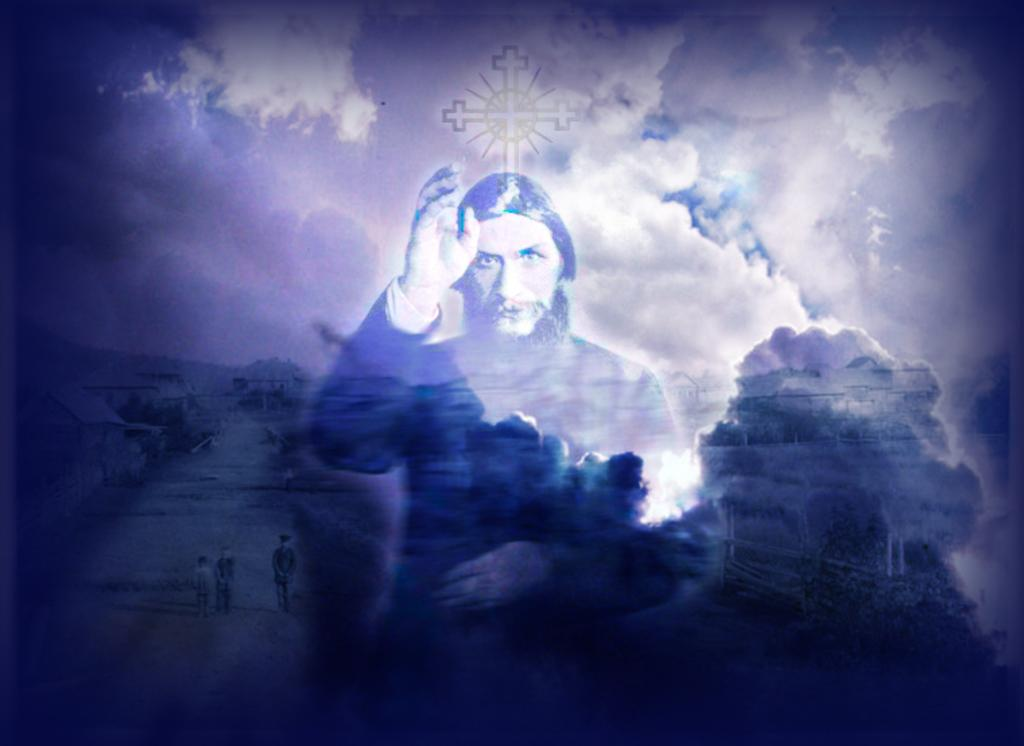What type of image is present in the picture? There is a graphical image in the picture. What are the people in the picture doing? There are people walking in the picture. How many humans are visible in the picture? There is another human in the picture, making a total of three people. What symbol can be seen in the picture? There is a cross symbol in the picture. What is visible in the sky in the picture? Clouds are visible in the sky. What type of nerve is visible in the picture? There is no nerve present in the picture; it features a graphical image, people walking, a cross symbol, and clouds in the sky. What question is being asked in the picture? There is no question present in the picture; it is a visual representation of various elements. 